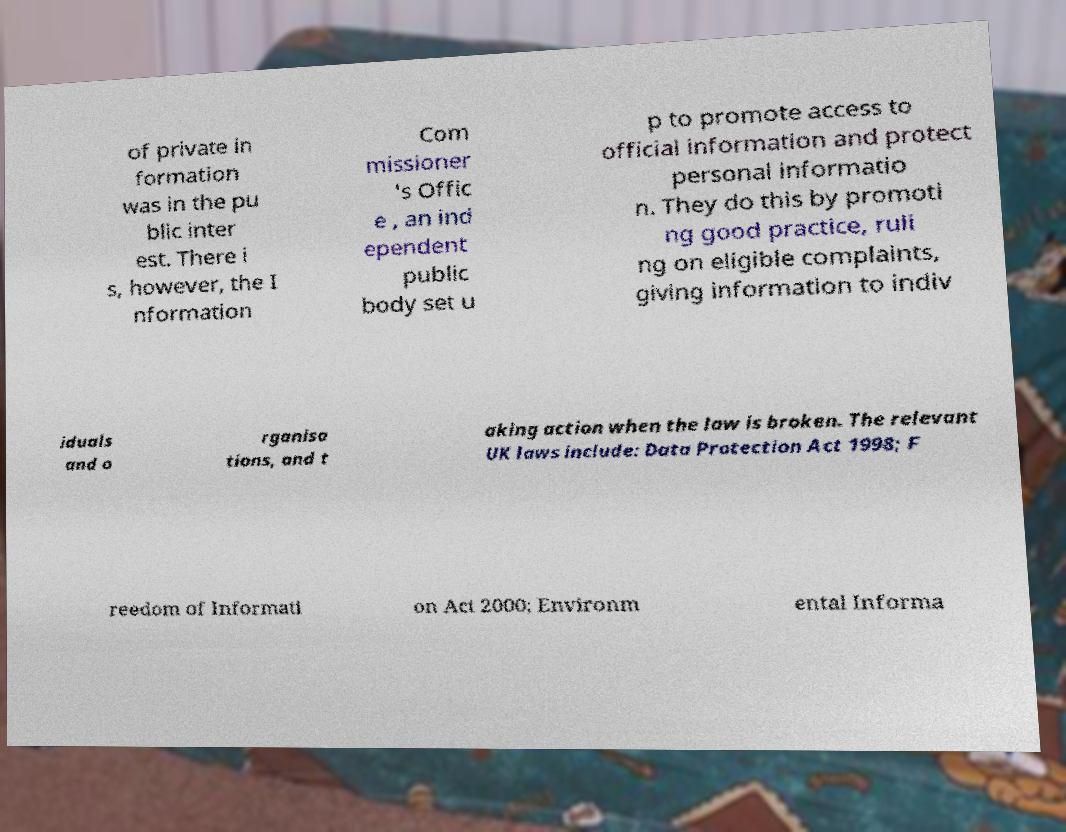What messages or text are displayed in this image? I need them in a readable, typed format. of private in formation was in the pu blic inter est. There i s, however, the I nformation Com missioner 's Offic e , an ind ependent public body set u p to promote access to official information and protect personal informatio n. They do this by promoti ng good practice, ruli ng on eligible complaints, giving information to indiv iduals and o rganisa tions, and t aking action when the law is broken. The relevant UK laws include: Data Protection Act 1998; F reedom of Informati on Act 2000; Environm ental Informa 